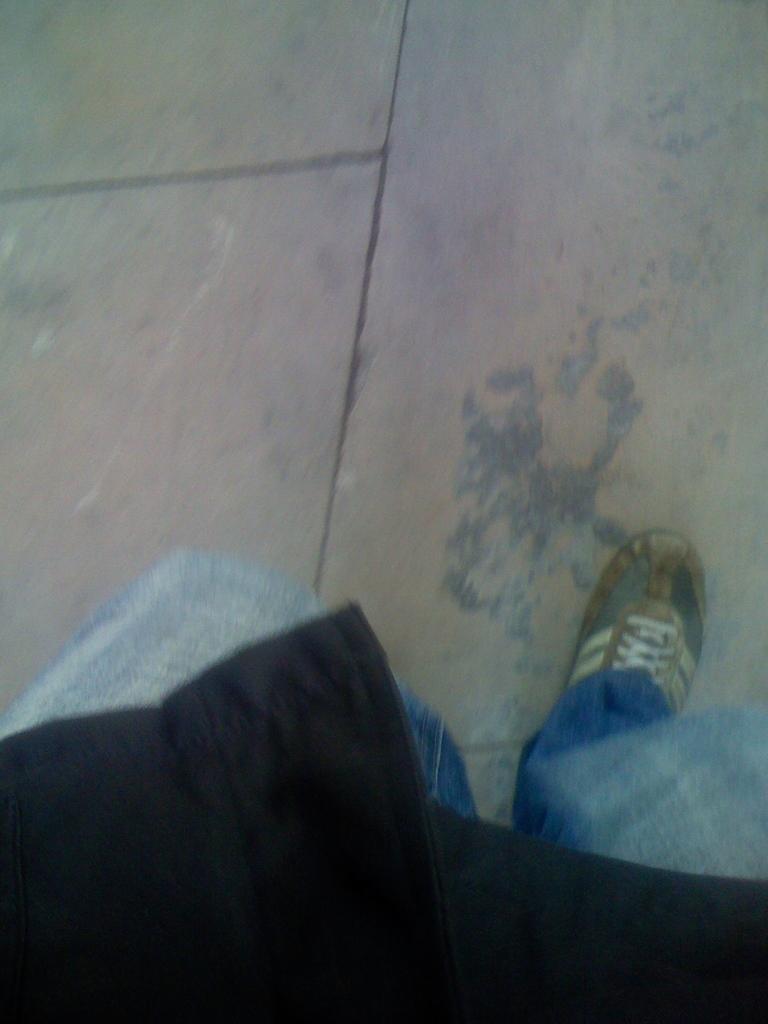In one or two sentences, can you explain what this image depicts? In this picture I can see a human and I can see floor. 